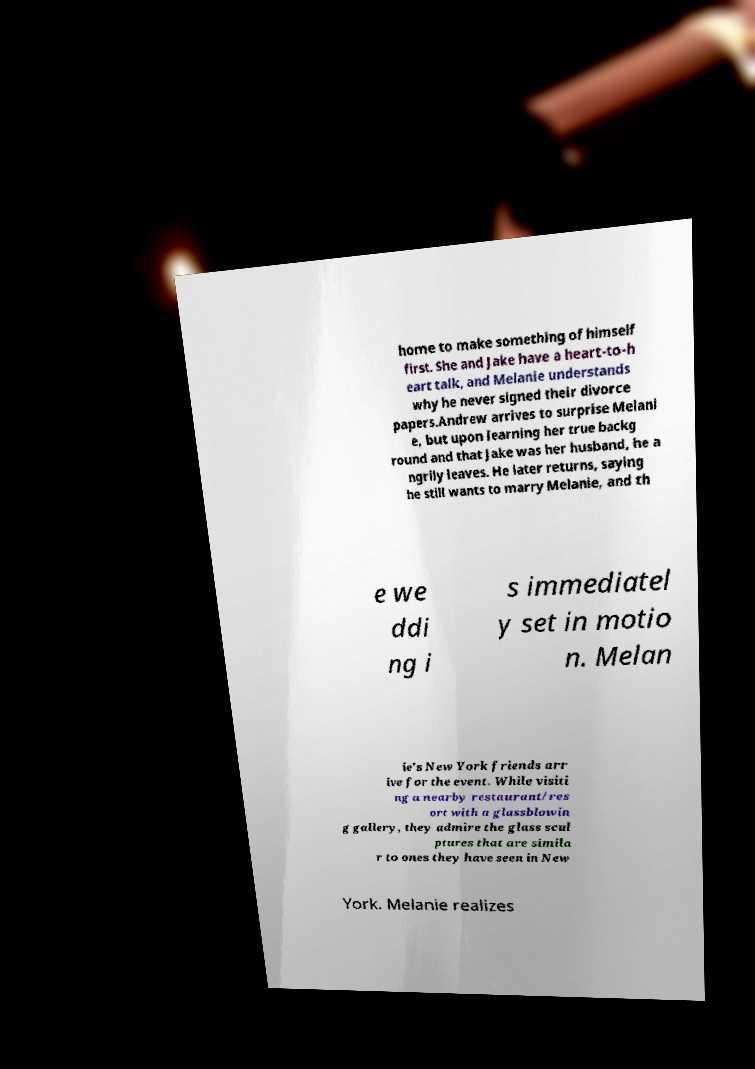I need the written content from this picture converted into text. Can you do that? home to make something of himself first. She and Jake have a heart-to-h eart talk, and Melanie understands why he never signed their divorce papers.Andrew arrives to surprise Melani e, but upon learning her true backg round and that Jake was her husband, he a ngrily leaves. He later returns, saying he still wants to marry Melanie, and th e we ddi ng i s immediatel y set in motio n. Melan ie's New York friends arr ive for the event. While visiti ng a nearby restaurant/res ort with a glassblowin g gallery, they admire the glass scul ptures that are simila r to ones they have seen in New York. Melanie realizes 